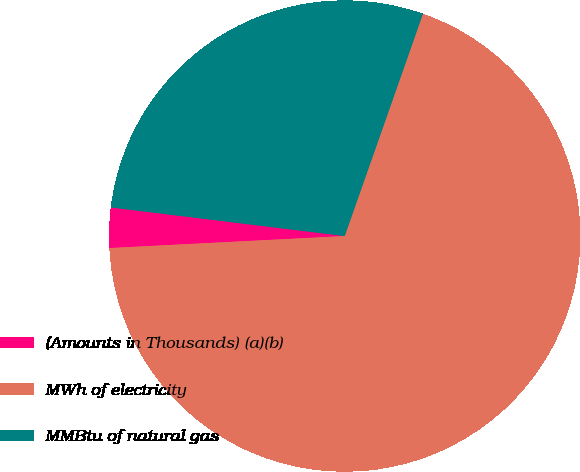Convert chart to OTSL. <chart><loc_0><loc_0><loc_500><loc_500><pie_chart><fcel>(Amounts in Thousands) (a)(b)<fcel>MWh of electricity<fcel>MMBtu of natural gas<nl><fcel>2.75%<fcel>68.81%<fcel>28.45%<nl></chart> 